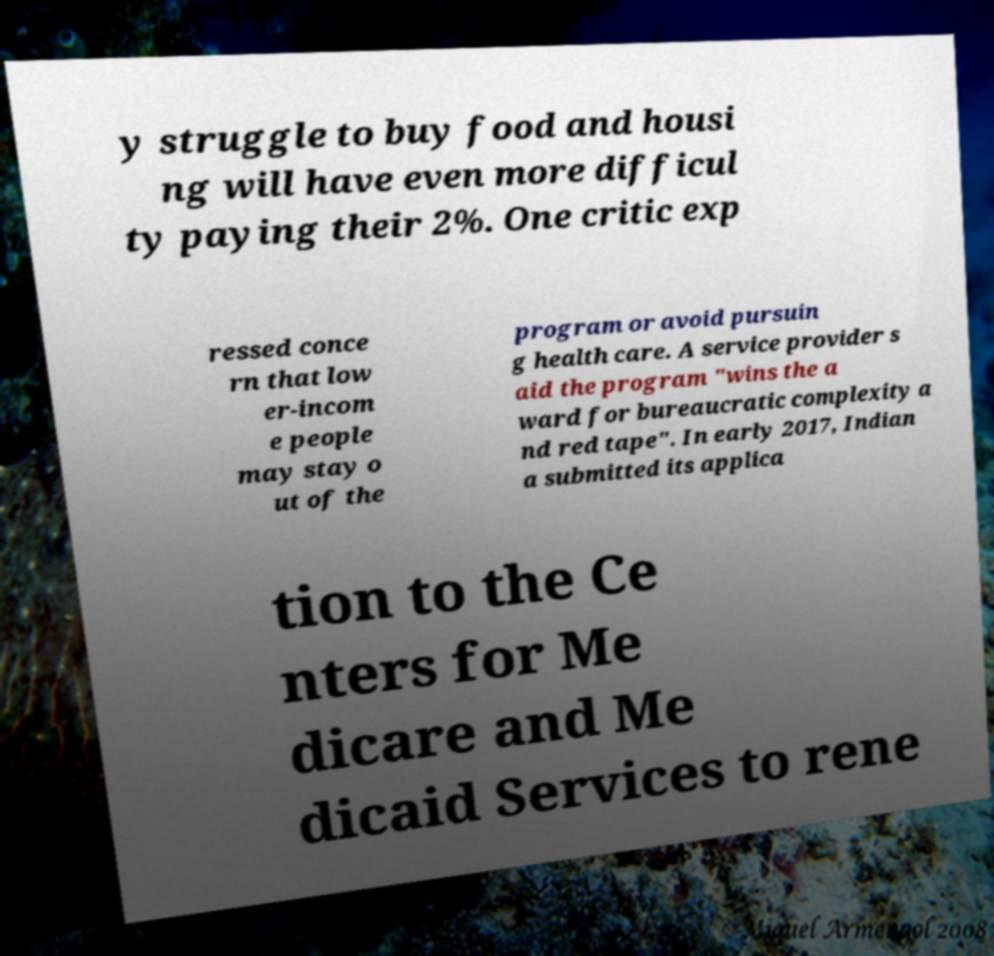Can you accurately transcribe the text from the provided image for me? y struggle to buy food and housi ng will have even more difficul ty paying their 2%. One critic exp ressed conce rn that low er-incom e people may stay o ut of the program or avoid pursuin g health care. A service provider s aid the program "wins the a ward for bureaucratic complexity a nd red tape". In early 2017, Indian a submitted its applica tion to the Ce nters for Me dicare and Me dicaid Services to rene 